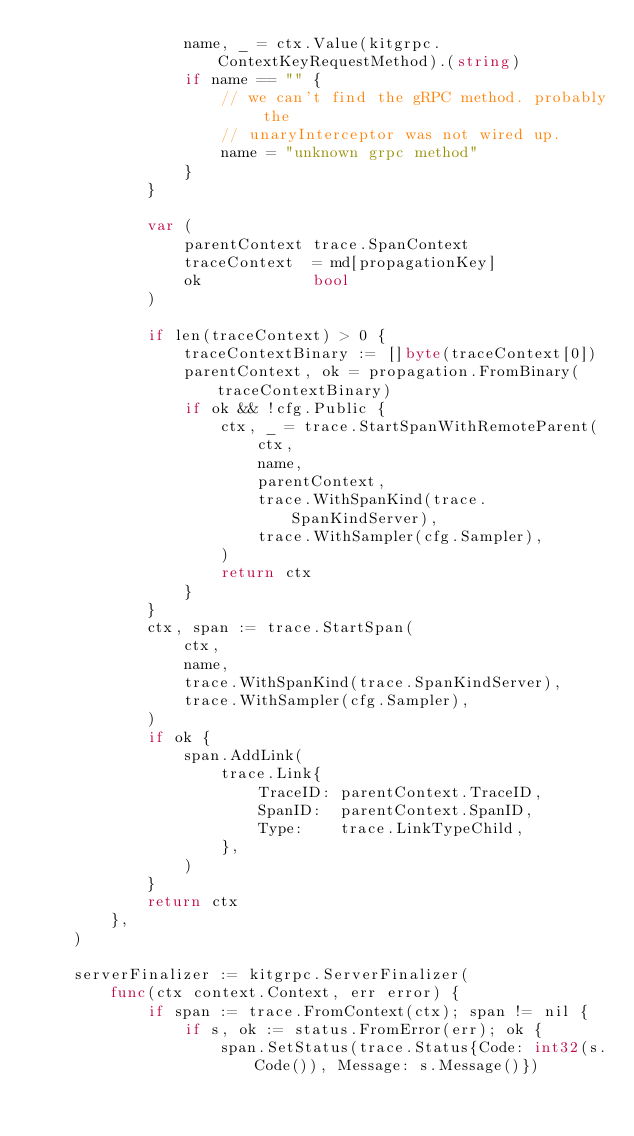<code> <loc_0><loc_0><loc_500><loc_500><_Go_>				name, _ = ctx.Value(kitgrpc.ContextKeyRequestMethod).(string)
				if name == "" {
					// we can't find the gRPC method. probably the
					// unaryInterceptor was not wired up.
					name = "unknown grpc method"
				}
			}

			var (
				parentContext trace.SpanContext
				traceContext  = md[propagationKey]
				ok            bool
			)

			if len(traceContext) > 0 {
				traceContextBinary := []byte(traceContext[0])
				parentContext, ok = propagation.FromBinary(traceContextBinary)
				if ok && !cfg.Public {
					ctx, _ = trace.StartSpanWithRemoteParent(
						ctx,
						name,
						parentContext,
						trace.WithSpanKind(trace.SpanKindServer),
						trace.WithSampler(cfg.Sampler),
					)
					return ctx
				}
			}
			ctx, span := trace.StartSpan(
				ctx,
				name,
				trace.WithSpanKind(trace.SpanKindServer),
				trace.WithSampler(cfg.Sampler),
			)
			if ok {
				span.AddLink(
					trace.Link{
						TraceID: parentContext.TraceID,
						SpanID:  parentContext.SpanID,
						Type:    trace.LinkTypeChild,
					},
				)
			}
			return ctx
		},
	)

	serverFinalizer := kitgrpc.ServerFinalizer(
		func(ctx context.Context, err error) {
			if span := trace.FromContext(ctx); span != nil {
				if s, ok := status.FromError(err); ok {
					span.SetStatus(trace.Status{Code: int32(s.Code()), Message: s.Message()})</code> 